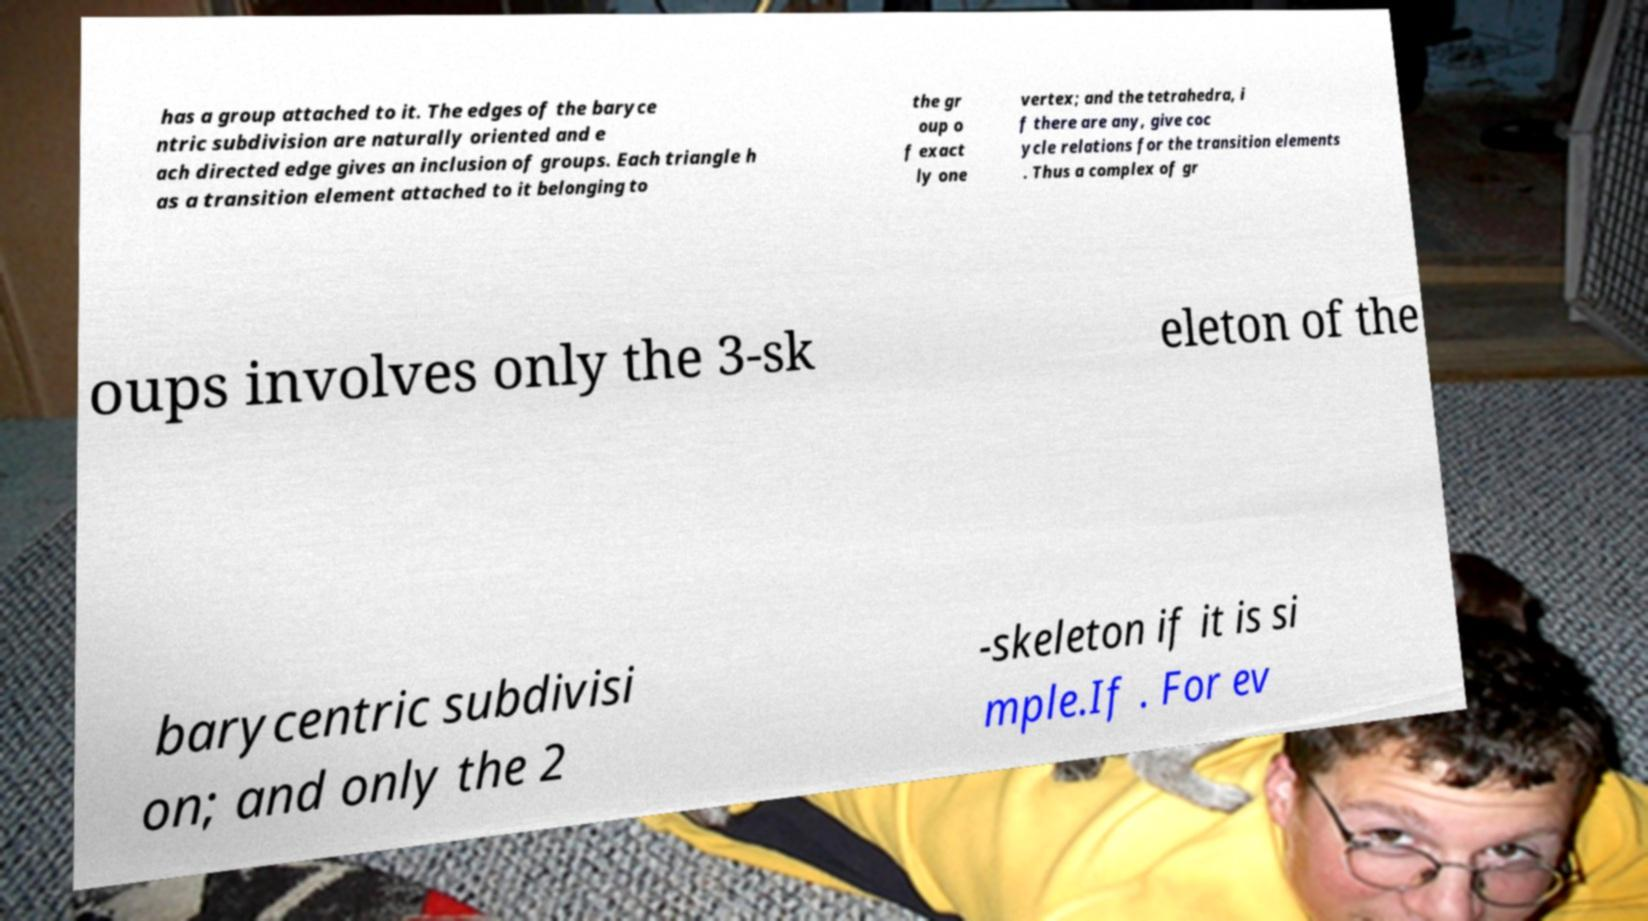I need the written content from this picture converted into text. Can you do that? has a group attached to it. The edges of the baryce ntric subdivision are naturally oriented and e ach directed edge gives an inclusion of groups. Each triangle h as a transition element attached to it belonging to the gr oup o f exact ly one vertex; and the tetrahedra, i f there are any, give coc ycle relations for the transition elements . Thus a complex of gr oups involves only the 3-sk eleton of the barycentric subdivisi on; and only the 2 -skeleton if it is si mple.If . For ev 